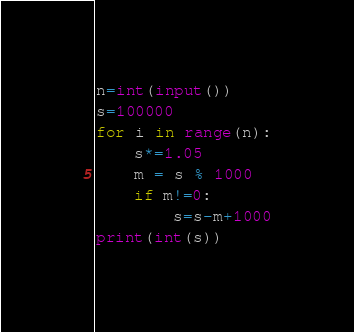Convert code to text. <code><loc_0><loc_0><loc_500><loc_500><_Python_>n=int(input())
s=100000
for i in range(n):
    s*=1.05
    m = s % 1000
    if m!=0:
        s=s-m+1000
print(int(s))
</code> 